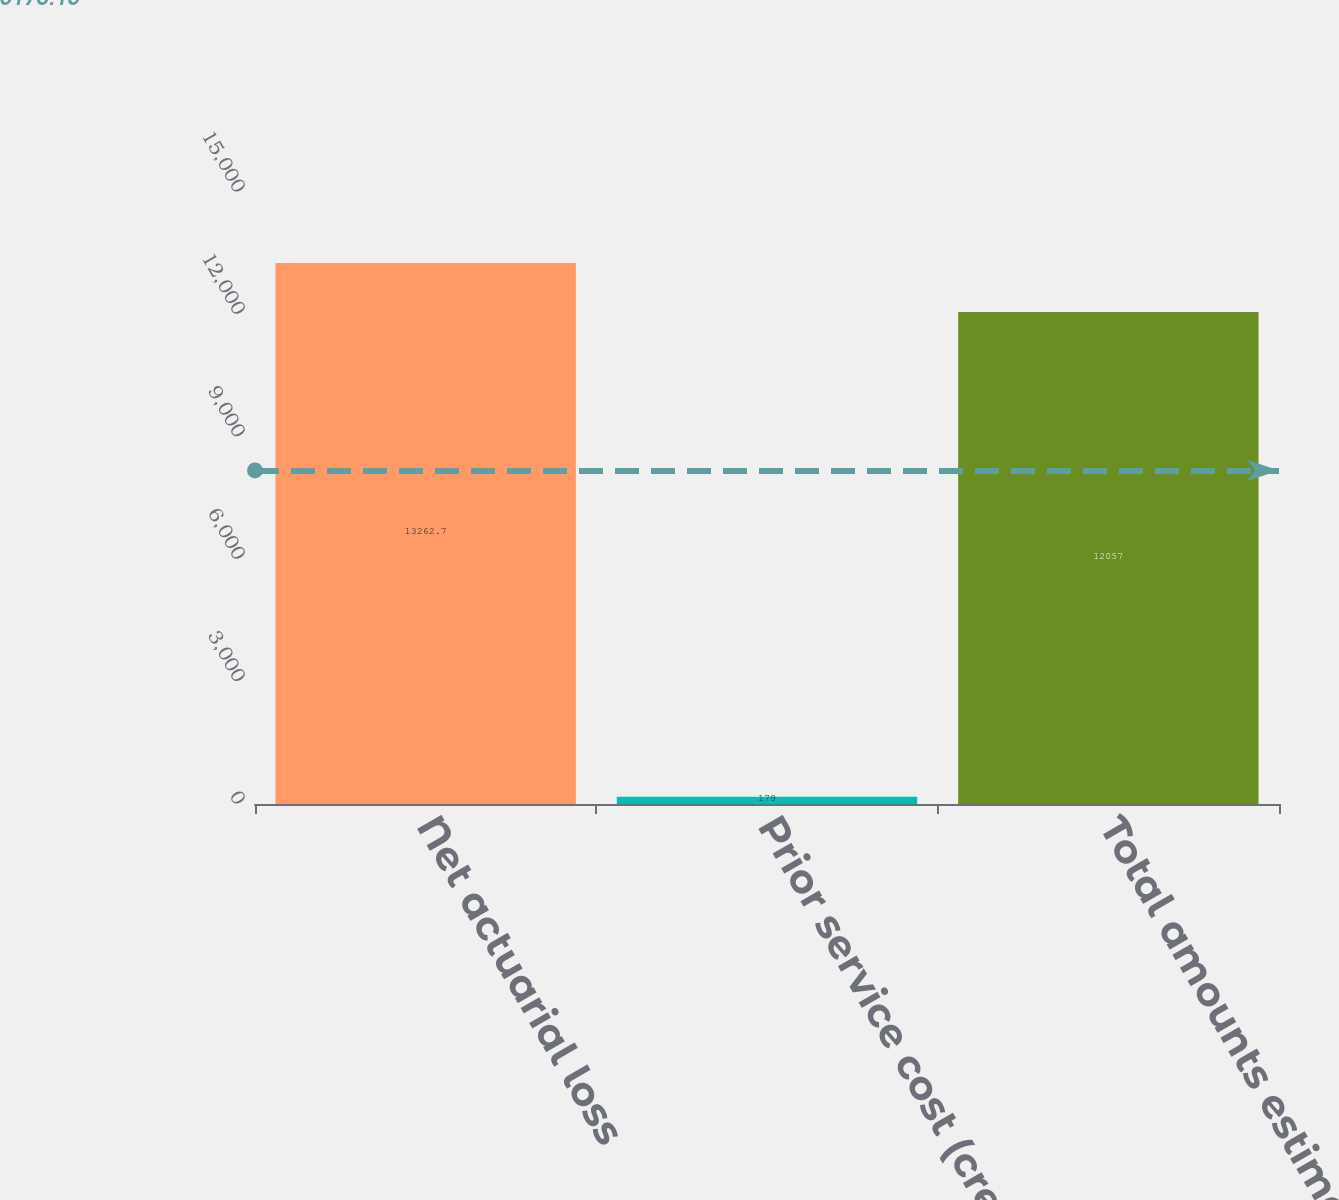Convert chart to OTSL. <chart><loc_0><loc_0><loc_500><loc_500><bar_chart><fcel>Net actuarial loss<fcel>Prior service cost (credit)<fcel>Total amounts estimated to be<nl><fcel>13262.7<fcel>179<fcel>12057<nl></chart> 